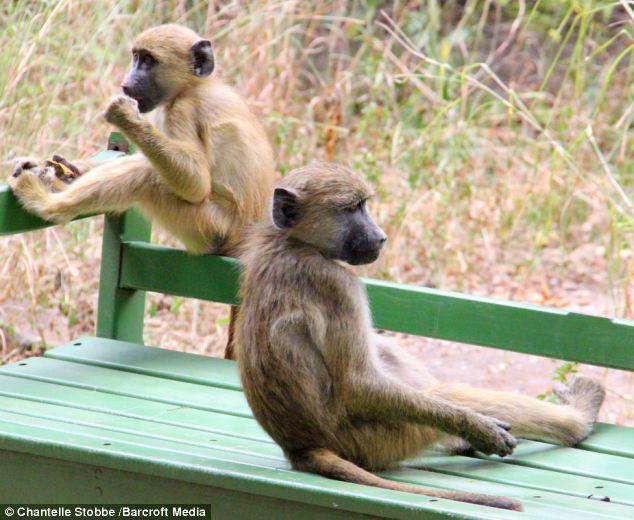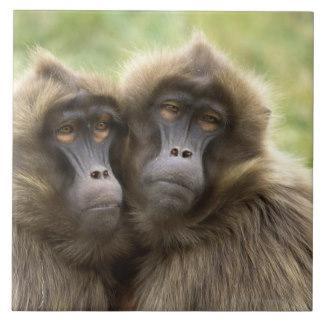The first image is the image on the left, the second image is the image on the right. Evaluate the accuracy of this statement regarding the images: "The right image shows a silvery long haired monkey sitting on its pink rear, and the left image shows two monkeys with matching coloring.". Is it true? Answer yes or no. No. The first image is the image on the left, the second image is the image on the right. Examine the images to the left and right. Is the description "There are more primates in the image on the left." accurate? Answer yes or no. No. 